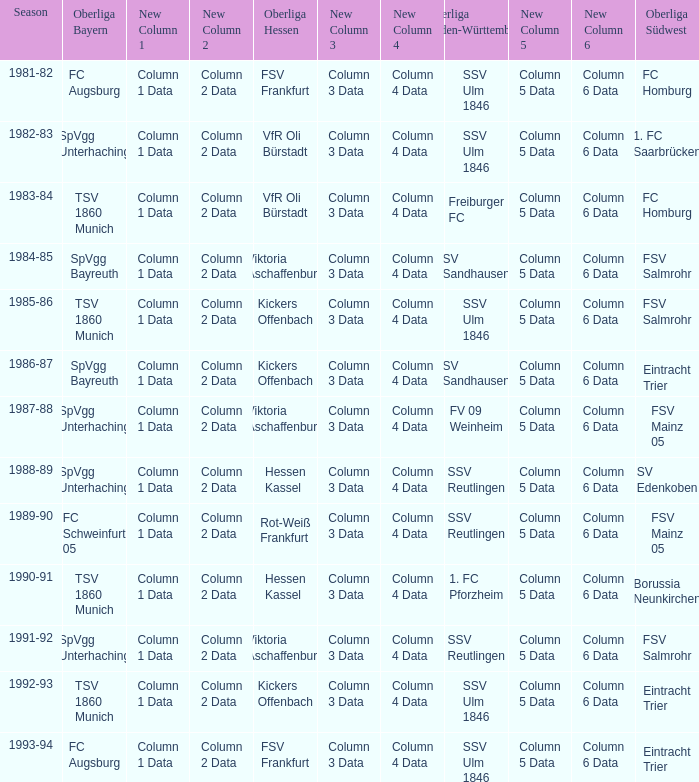Which Oberliga Baden-Württemberg has an Oberliga Hessen of fsv frankfurt in 1993-94? SSV Ulm 1846. 